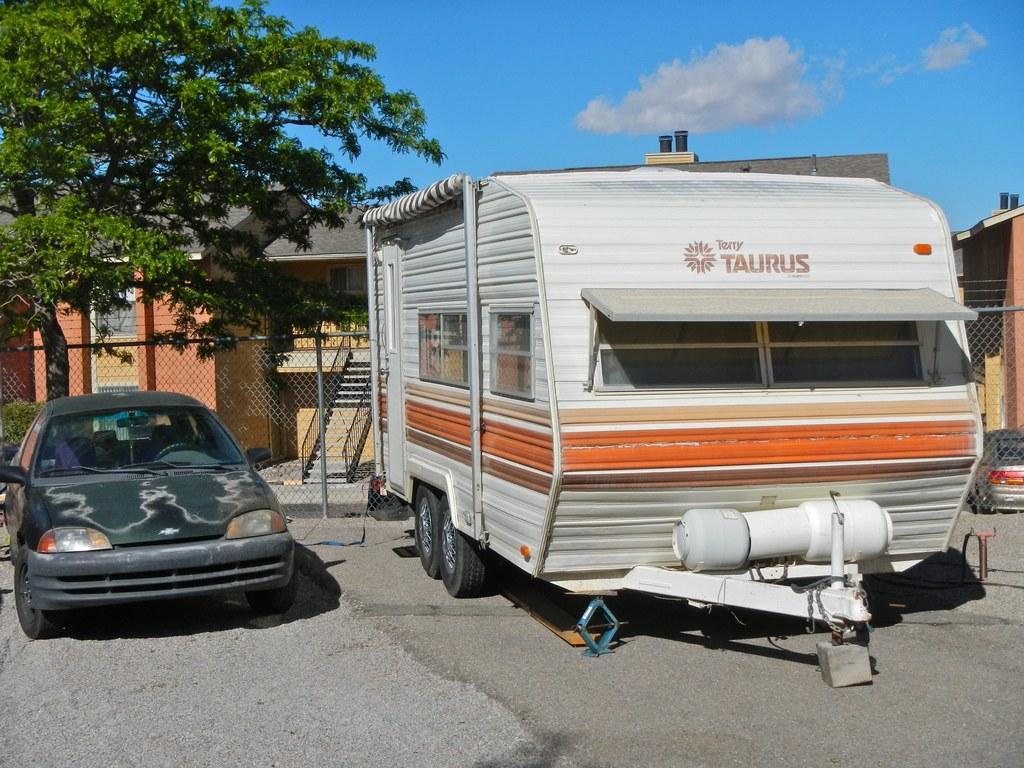Please provide a concise description of this image. In this image we can see a truck which is of white and red color is parked and there is black color car which is also parked and in the background of the image there is fencing, trees, there are some houses and clear sky. 